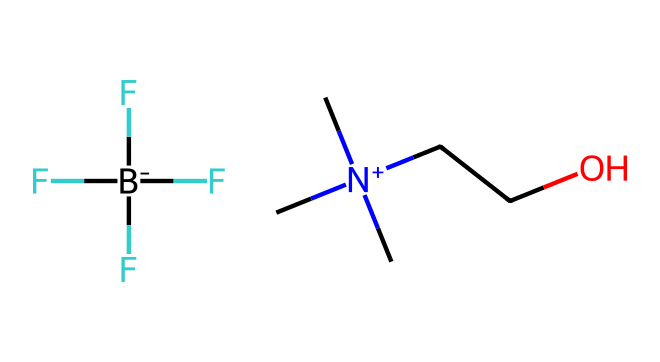What type of ionic liquid is represented by this SMILES? The structure includes a quaternary ammonium cation and a tetrafluoroborate anion, which are characteristic of ionic liquids.
Answer: quaternary ammonium How many carbon atoms are present in the structure? By analyzing the SMILES representation, we can count the carbon atoms in the cation part, which shows five carbon atoms.
Answer: five What anion is associated with the cation in this ionic liquid? The SMILES shows a part `[B-](F)(F)(F)F` which indicates that the anion is tetrafluoroborate, characterized by a boron atom surrounded by four fluorine atoms.
Answer: tetrafluoroborate Which element in the structure is responsible for the ionic character? Ionic character is attributed to the presence of charged species, specifically the nitrogen in the quaternary ammonium, which carries a positive charge.
Answer: nitrogen How does this ionic liquid's structure contribute to its thermal stability? The bulky nature of the cation provides steric hindrance and reduces volatility, while the strong bonds to fluorine in the anion contribute to thermal stability, making it effective for heat transfer.
Answer: steric hindrance and strong bonds 